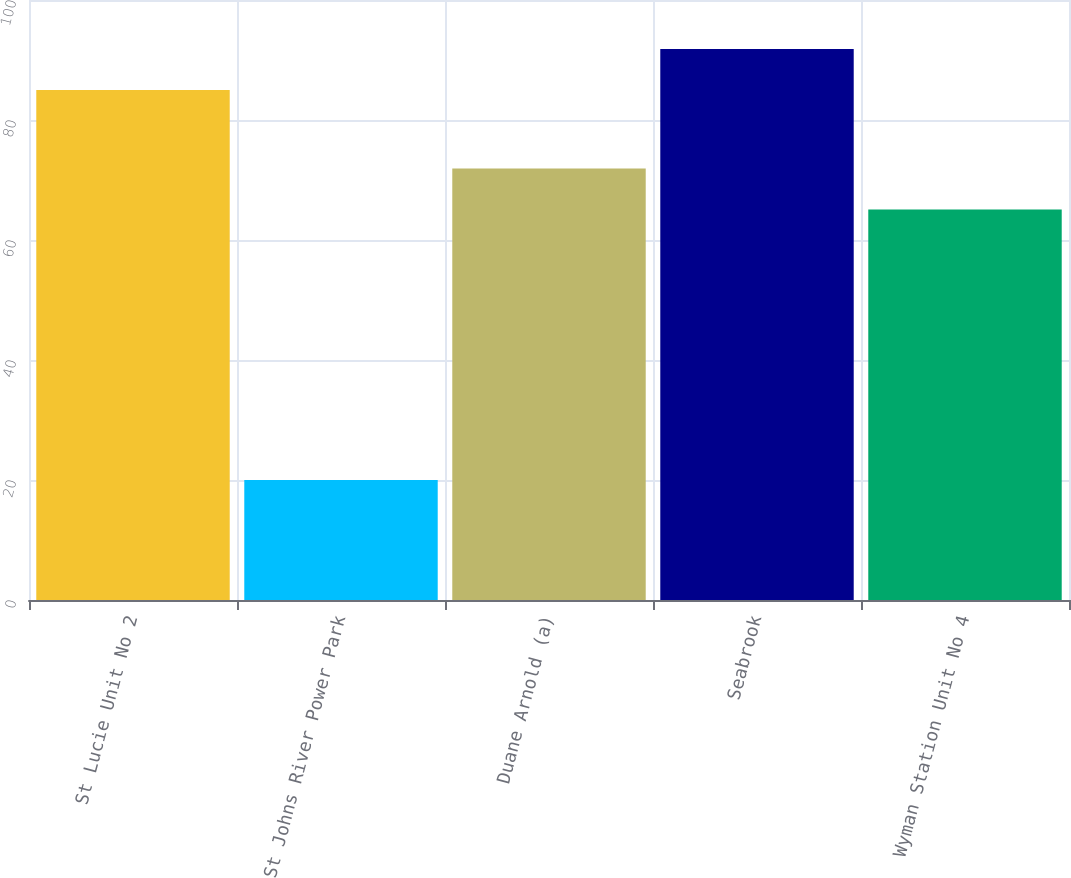Convert chart. <chart><loc_0><loc_0><loc_500><loc_500><bar_chart><fcel>St Lucie Unit No 2<fcel>St Johns River Power Park<fcel>Duane Arnold (a)<fcel>Seabrook<fcel>Wyman Station Unit No 4<nl><fcel>85<fcel>20<fcel>71.92<fcel>91.82<fcel>65.1<nl></chart> 